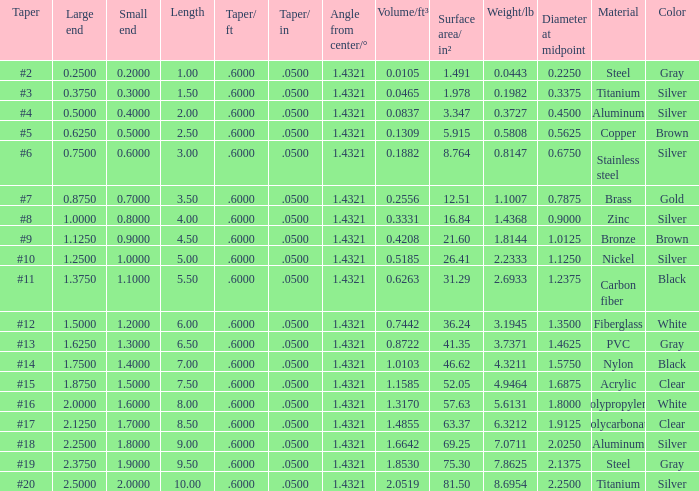Which Taper/in that has a Small end larger than 0.7000000000000001, and a Taper of #19, and a Large end larger than 2.375? None. 